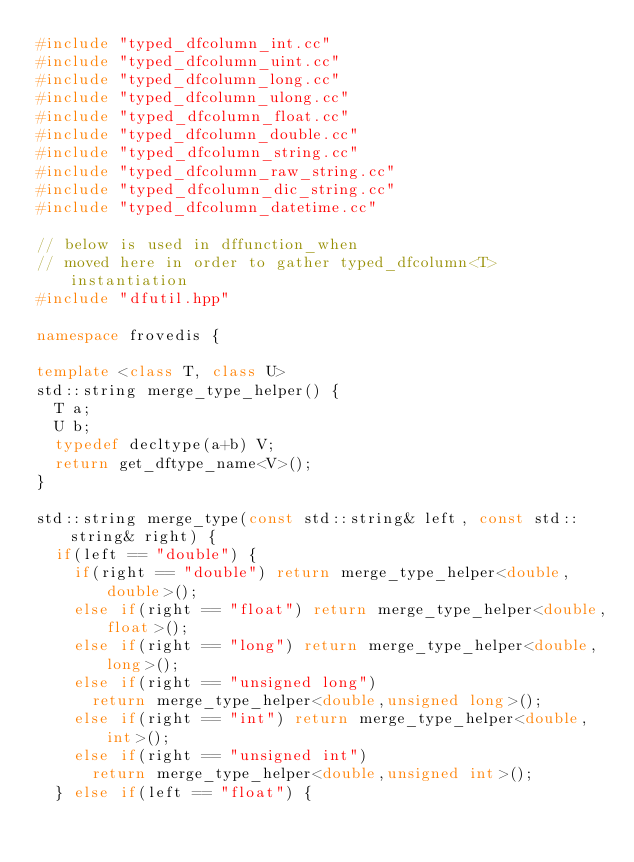<code> <loc_0><loc_0><loc_500><loc_500><_C++_>#include "typed_dfcolumn_int.cc"
#include "typed_dfcolumn_uint.cc"
#include "typed_dfcolumn_long.cc"
#include "typed_dfcolumn_ulong.cc"
#include "typed_dfcolumn_float.cc"
#include "typed_dfcolumn_double.cc"
#include "typed_dfcolumn_string.cc"
#include "typed_dfcolumn_raw_string.cc"
#include "typed_dfcolumn_dic_string.cc"
#include "typed_dfcolumn_datetime.cc"

// below is used in dffunction_when
// moved here in order to gather typed_dfcolumn<T> instantiation
#include "dfutil.hpp"

namespace frovedis {

template <class T, class U>
std::string merge_type_helper() {
  T a;
  U b;
  typedef decltype(a+b) V;
  return get_dftype_name<V>();
}

std::string merge_type(const std::string& left, const std::string& right) {
  if(left == "double") {
    if(right == "double") return merge_type_helper<double,double>();
    else if(right == "float") return merge_type_helper<double,float>();
    else if(right == "long") return merge_type_helper<double,long>();
    else if(right == "unsigned long")
      return merge_type_helper<double,unsigned long>();
    else if(right == "int") return merge_type_helper<double,int>();
    else if(right == "unsigned int")
      return merge_type_helper<double,unsigned int>();
  } else if(left == "float") {</code> 